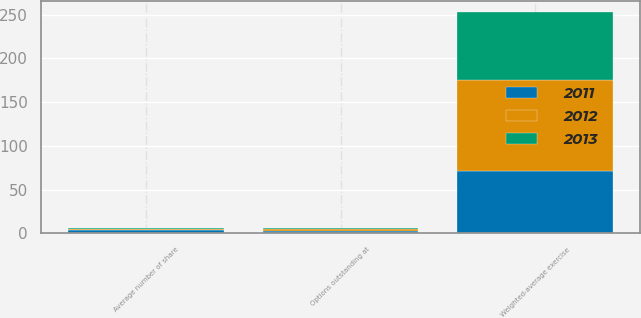Convert chart. <chart><loc_0><loc_0><loc_500><loc_500><stacked_bar_chart><ecel><fcel>Average number of share<fcel>Weighted-average exercise<fcel>Options outstanding at<nl><fcel>2012<fcel>1.1<fcel>103.29<fcel>1.8<nl><fcel>2013<fcel>1.1<fcel>78.54<fcel>1.7<nl><fcel>2011<fcel>3.6<fcel>71.49<fcel>3<nl></chart> 